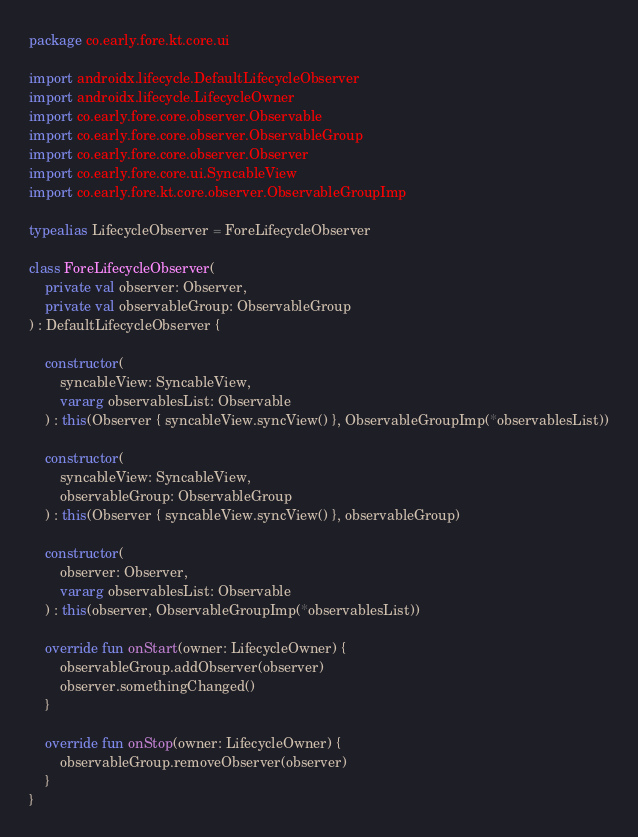Convert code to text. <code><loc_0><loc_0><loc_500><loc_500><_Kotlin_>package co.early.fore.kt.core.ui

import androidx.lifecycle.DefaultLifecycleObserver
import androidx.lifecycle.LifecycleOwner
import co.early.fore.core.observer.Observable
import co.early.fore.core.observer.ObservableGroup
import co.early.fore.core.observer.Observer
import co.early.fore.core.ui.SyncableView
import co.early.fore.kt.core.observer.ObservableGroupImp

typealias LifecycleObserver = ForeLifecycleObserver

class ForeLifecycleObserver(
    private val observer: Observer,
    private val observableGroup: ObservableGroup
) : DefaultLifecycleObserver {

    constructor(
        syncableView: SyncableView,
        vararg observablesList: Observable
    ) : this(Observer { syncableView.syncView() }, ObservableGroupImp(*observablesList))

    constructor(
        syncableView: SyncableView,
        observableGroup: ObservableGroup
    ) : this(Observer { syncableView.syncView() }, observableGroup)

    constructor(
        observer: Observer,
        vararg observablesList: Observable
    ) : this(observer, ObservableGroupImp(*observablesList))

    override fun onStart(owner: LifecycleOwner) {
        observableGroup.addObserver(observer)
        observer.somethingChanged()
    }

    override fun onStop(owner: LifecycleOwner) {
        observableGroup.removeObserver(observer)
    }
}
</code> 